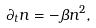<formula> <loc_0><loc_0><loc_500><loc_500>\partial _ { t } n = - \beta n ^ { 2 } ,</formula> 